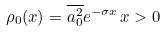<formula> <loc_0><loc_0><loc_500><loc_500>\rho _ { 0 } ( x ) = \overline { a ^ { 2 } _ { 0 } } e ^ { - \sigma x } \, x > 0</formula> 